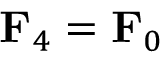<formula> <loc_0><loc_0><loc_500><loc_500>F _ { 4 } = F _ { 0 }</formula> 